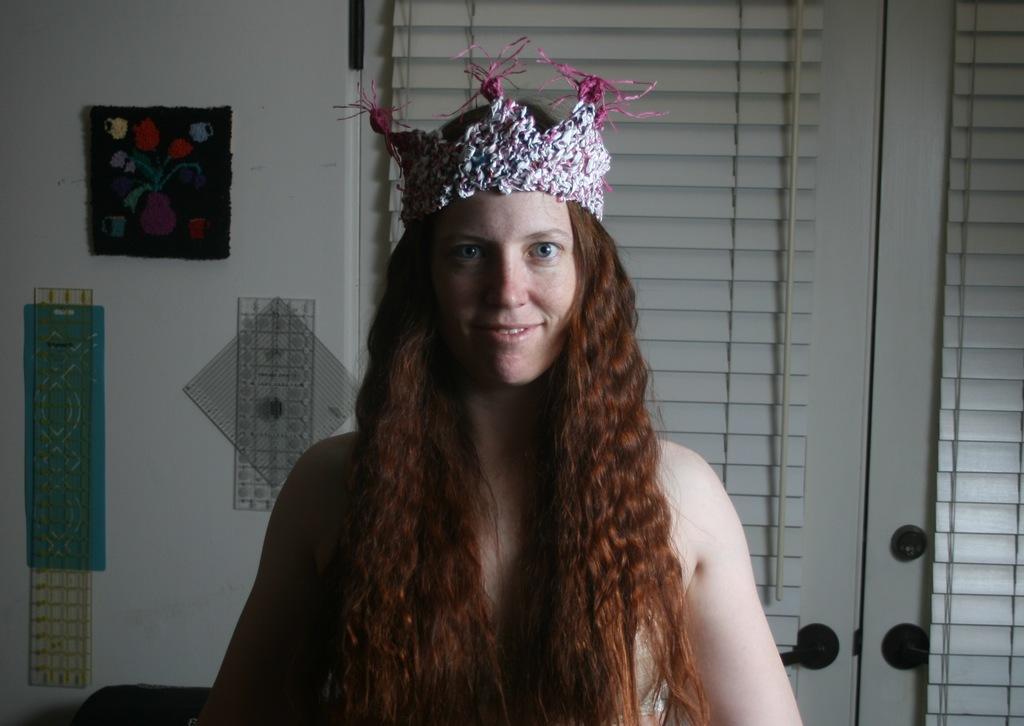Can you describe this image briefly? This is an inside view. Here I can see a woman smiling and giving pose for the picture. I can see a crown on her head. At the back of her there is a window along with the wall. On the left side, I can see few posts are attached to the wall. 